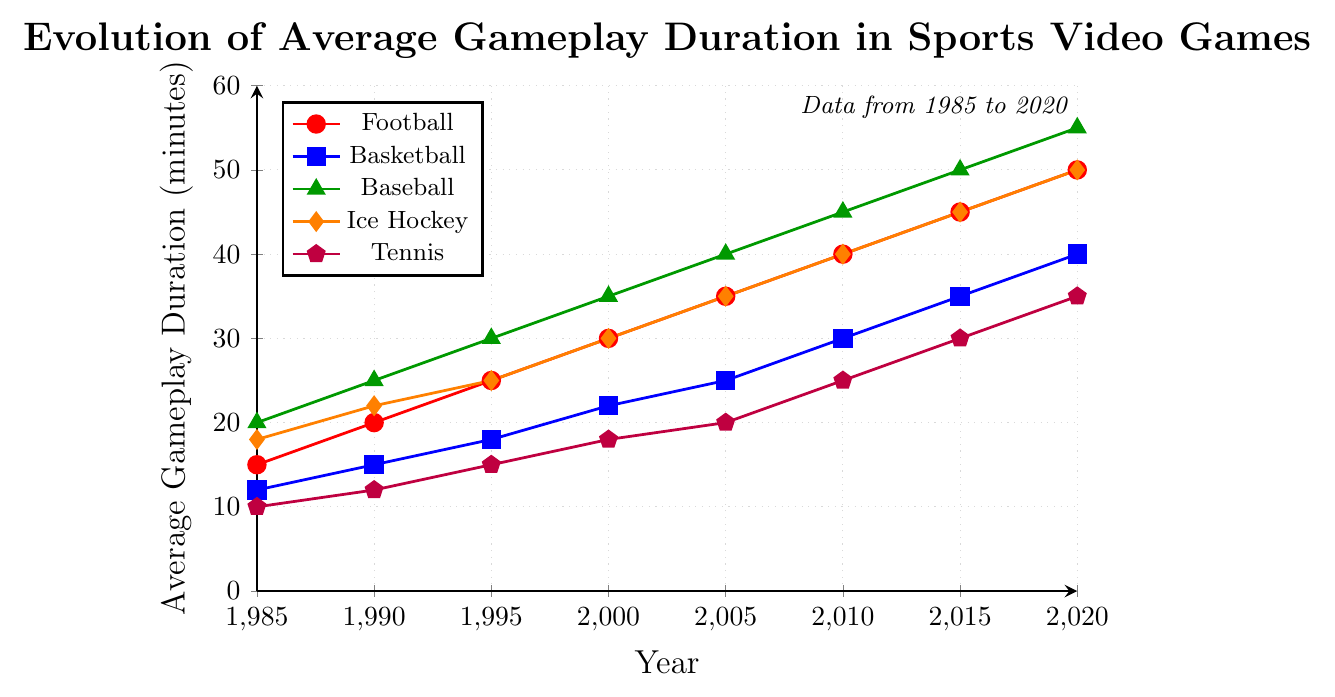What sport type had the longest average gameplay duration in 2000? Reviewing the figure, we observe the different plot lines representing each sport type, and for the year 2000, the green line (Baseball) reaches the highest value, which is 35 minutes.
Answer: Baseball Comparing 1995 and 2015, how much did the average gameplay duration for Basketball increase? The blue line representing Basketball shows an increase from 18 minutes in 1995 to 35 minutes in 2015. The difference is calculated by subtracting these values: 35 - 18 = 17 minutes.
Answer: 17 minutes In 1985, which sport type had the shortest average gameplay duration, and what was it? By looking at the starting points of each plot line in 1985, we note that the purple line (Tennis) is the lowest, marking 10 minutes.
Answer: Tennis, 10 minutes What is the combined average gameplay duration for Football and Ice Hockey in 2010? From the plot, the red line for Football in 2010 is at 40 minutes and the orange line for Ice Hockey is at 40 minutes as well. Adding these gives 40 + 40 = 80 minutes.
Answer: 80 minutes Between which consecutive years did Baseball see the highest increase in average gameplay duration? Observing the green line (Baseball), the biggest jump happens between 2015 (50 minutes) to 2020 (55 minutes). The difference is 55 - 50 = 5 minutes.
Answer: 2015 to 2020 How many sports had an average gameplay duration of at least 25 minutes in the year 2005? For the year 2005, the red (Football), blue (Basketball), green (Baseball), and orange (Ice Hockey) lines all cross 25 minutes, while the purple (Tennis) line is at 20 minutes. Therefore, 4 sports meet the criteria.
Answer: 4 sports Which sport experienced the least total increase in average gameplay duration from 1985 to 2020? Calculating the increase from 1985 to 2020 for each sport: 
- Football: 50 - 15 = 35 minutes
- Basketball: 40 - 12 = 28 minutes
- Baseball: 55 - 20 = 35 minutes
- Ice Hockey: 50 - 18 = 32 minutes
- Tennis: 35 - 10 = 25 minutes
The smallest increase is for Tennis with 25 minutes.
Answer: Tennis What was the relative difference in average gameplay duration between Football and Tennis in 2020? Football has 50 minutes and Tennis has 35 minutes in 2020. The relative difference is found by (50 - 35) / 35 * 100% = 42.86%.
Answer: 42.86% Identify the two years where the average gameplay duration for all five sports are observed to increase consistently. Inspecting each sport type visually, we notice that for all the lines (representing different sports), the years 2000 to 2005 and 2015 to 2020 show a consistent upward trend for all lines.
Answer: 2000 to 2005, 2015 to 2020 